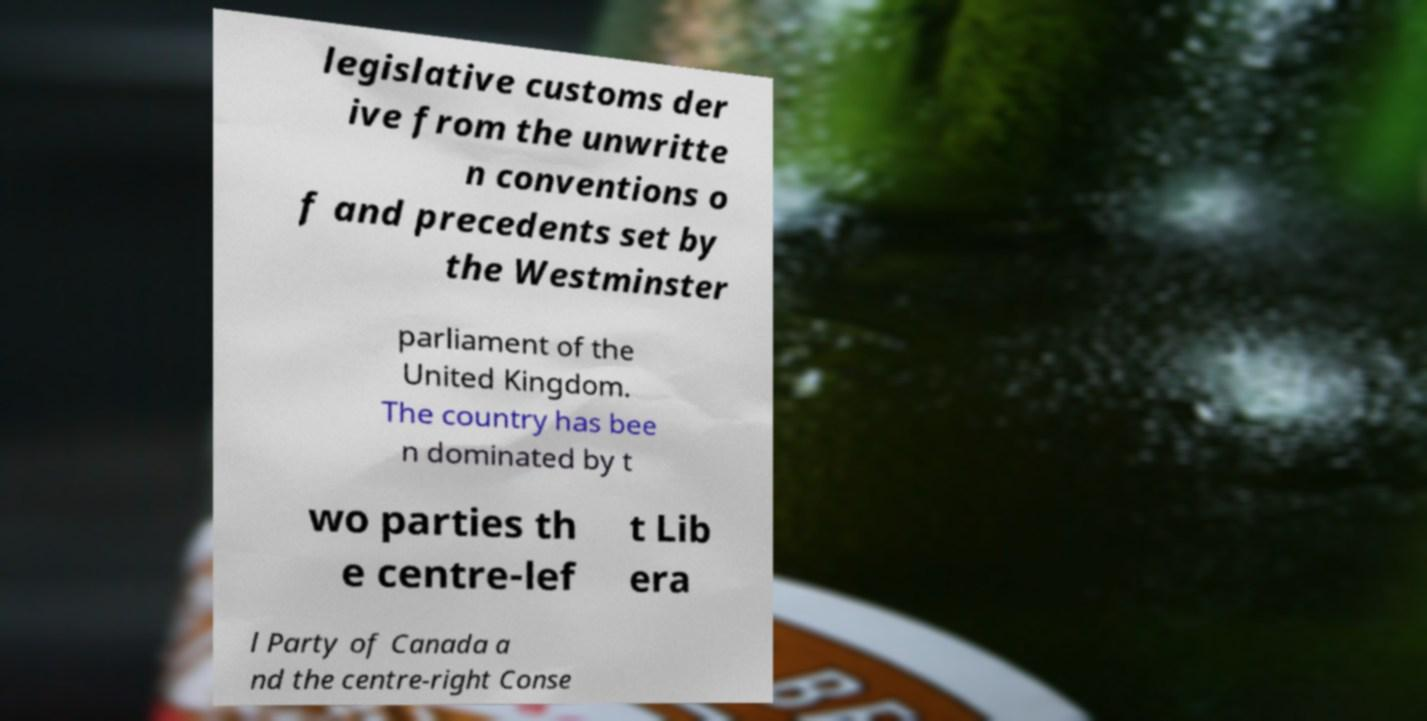Could you assist in decoding the text presented in this image and type it out clearly? legislative customs der ive from the unwritte n conventions o f and precedents set by the Westminster parliament of the United Kingdom. The country has bee n dominated by t wo parties th e centre-lef t Lib era l Party of Canada a nd the centre-right Conse 